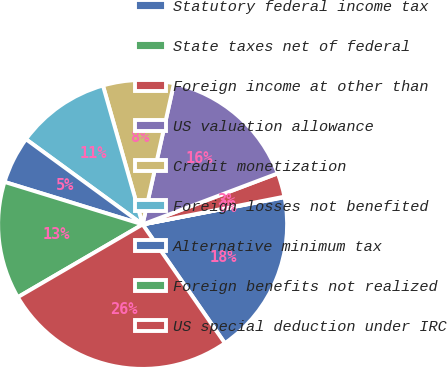<chart> <loc_0><loc_0><loc_500><loc_500><pie_chart><fcel>Statutory federal income tax<fcel>State taxes net of federal<fcel>Foreign income at other than<fcel>US valuation allowance<fcel>Credit monetization<fcel>Foreign losses not benefited<fcel>Alternative minimum tax<fcel>Foreign benefits not realized<fcel>US special deduction under IRC<nl><fcel>18.38%<fcel>0.06%<fcel>2.67%<fcel>15.77%<fcel>7.91%<fcel>10.53%<fcel>5.29%<fcel>13.15%<fcel>26.24%<nl></chart> 